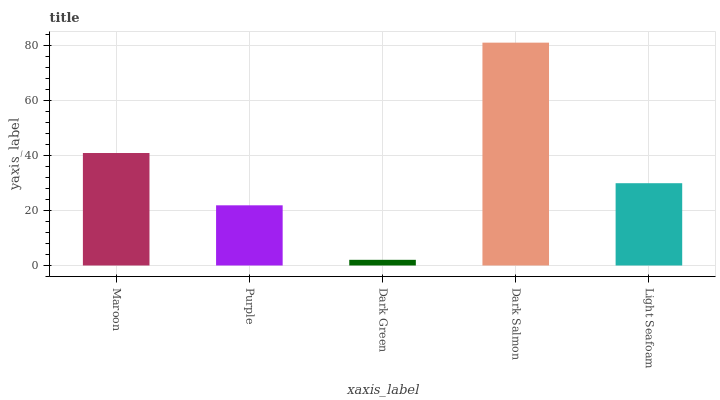Is Purple the minimum?
Answer yes or no. No. Is Purple the maximum?
Answer yes or no. No. Is Maroon greater than Purple?
Answer yes or no. Yes. Is Purple less than Maroon?
Answer yes or no. Yes. Is Purple greater than Maroon?
Answer yes or no. No. Is Maroon less than Purple?
Answer yes or no. No. Is Light Seafoam the high median?
Answer yes or no. Yes. Is Light Seafoam the low median?
Answer yes or no. Yes. Is Dark Green the high median?
Answer yes or no. No. Is Dark Salmon the low median?
Answer yes or no. No. 